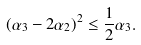<formula> <loc_0><loc_0><loc_500><loc_500>( \alpha _ { 3 } - 2 \alpha _ { 2 } ) ^ { 2 } \leq { \frac { 1 } { 2 } } \alpha _ { 3 } .</formula> 